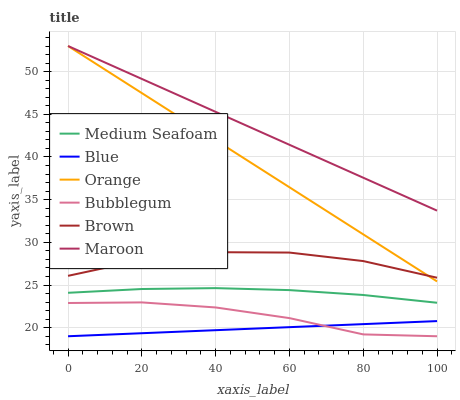Does Blue have the minimum area under the curve?
Answer yes or no. Yes. Does Maroon have the maximum area under the curve?
Answer yes or no. Yes. Does Brown have the minimum area under the curve?
Answer yes or no. No. Does Brown have the maximum area under the curve?
Answer yes or no. No. Is Orange the smoothest?
Answer yes or no. Yes. Is Brown the roughest?
Answer yes or no. Yes. Is Maroon the smoothest?
Answer yes or no. No. Is Maroon the roughest?
Answer yes or no. No. Does Blue have the lowest value?
Answer yes or no. Yes. Does Brown have the lowest value?
Answer yes or no. No. Does Orange have the highest value?
Answer yes or no. Yes. Does Brown have the highest value?
Answer yes or no. No. Is Medium Seafoam less than Maroon?
Answer yes or no. Yes. Is Brown greater than Bubblegum?
Answer yes or no. Yes. Does Orange intersect Brown?
Answer yes or no. Yes. Is Orange less than Brown?
Answer yes or no. No. Is Orange greater than Brown?
Answer yes or no. No. Does Medium Seafoam intersect Maroon?
Answer yes or no. No. 